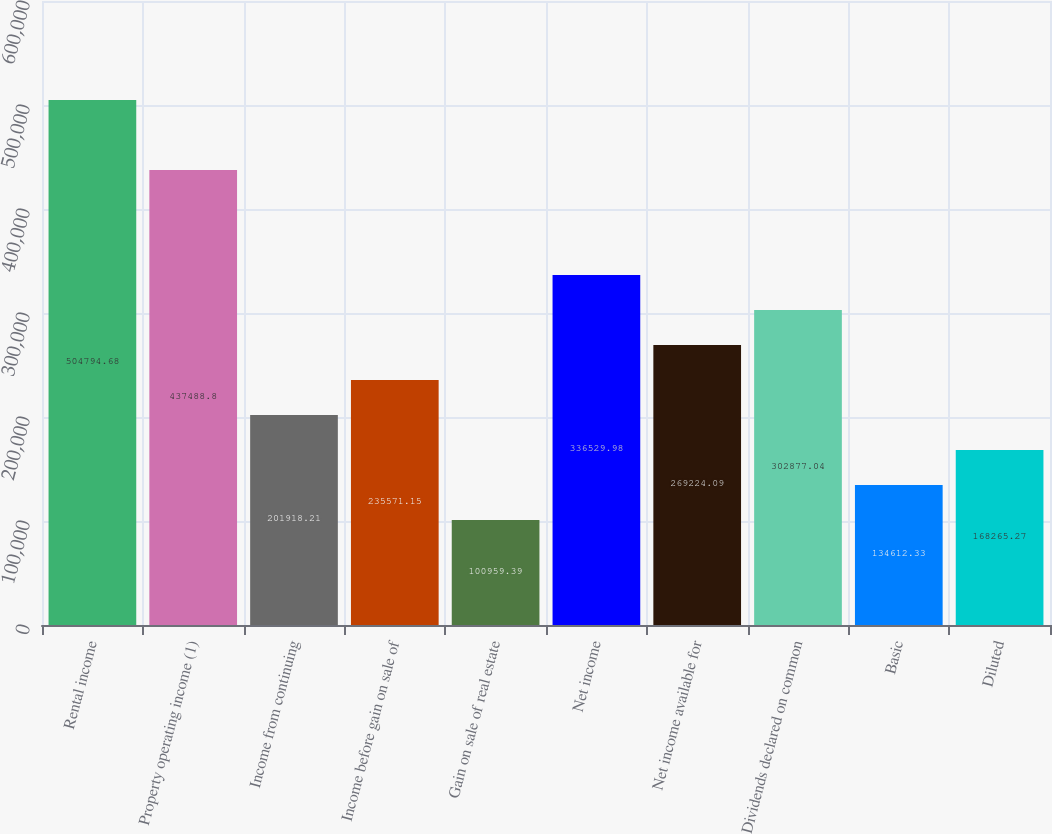<chart> <loc_0><loc_0><loc_500><loc_500><bar_chart><fcel>Rental income<fcel>Property operating income (1)<fcel>Income from continuing<fcel>Income before gain on sale of<fcel>Gain on sale of real estate<fcel>Net income<fcel>Net income available for<fcel>Dividends declared on common<fcel>Basic<fcel>Diluted<nl><fcel>504795<fcel>437489<fcel>201918<fcel>235571<fcel>100959<fcel>336530<fcel>269224<fcel>302877<fcel>134612<fcel>168265<nl></chart> 